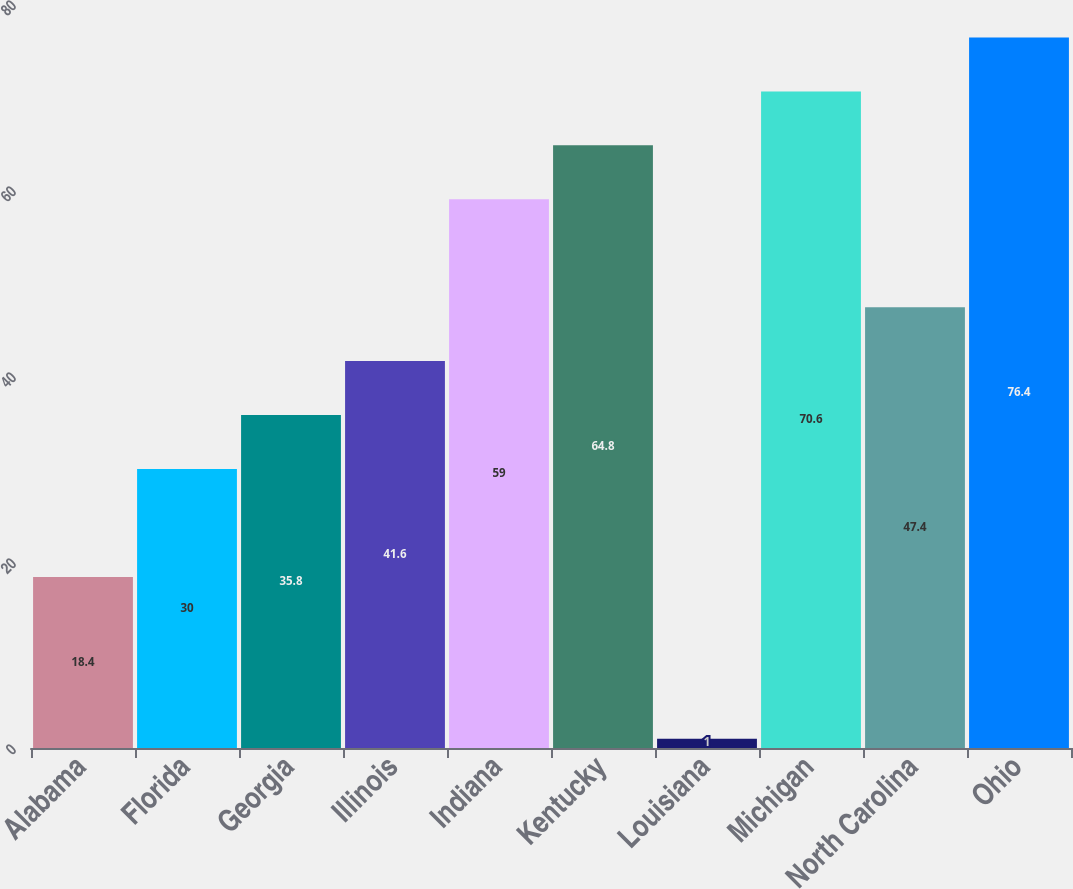<chart> <loc_0><loc_0><loc_500><loc_500><bar_chart><fcel>Alabama<fcel>Florida<fcel>Georgia<fcel>Illinois<fcel>Indiana<fcel>Kentucky<fcel>Louisiana<fcel>Michigan<fcel>North Carolina<fcel>Ohio<nl><fcel>18.4<fcel>30<fcel>35.8<fcel>41.6<fcel>59<fcel>64.8<fcel>1<fcel>70.6<fcel>47.4<fcel>76.4<nl></chart> 